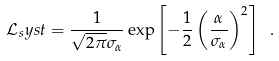Convert formula to latex. <formula><loc_0><loc_0><loc_500><loc_500>\mathcal { L } _ { s } y s t = \frac { 1 } { \sqrt { 2 \pi } \sigma _ { \alpha } } \exp \left [ { - \frac { 1 } { 2 } \left ( \frac { \alpha } { \sigma _ { \alpha } } \right ) ^ { 2 } } \right ] \ .</formula> 